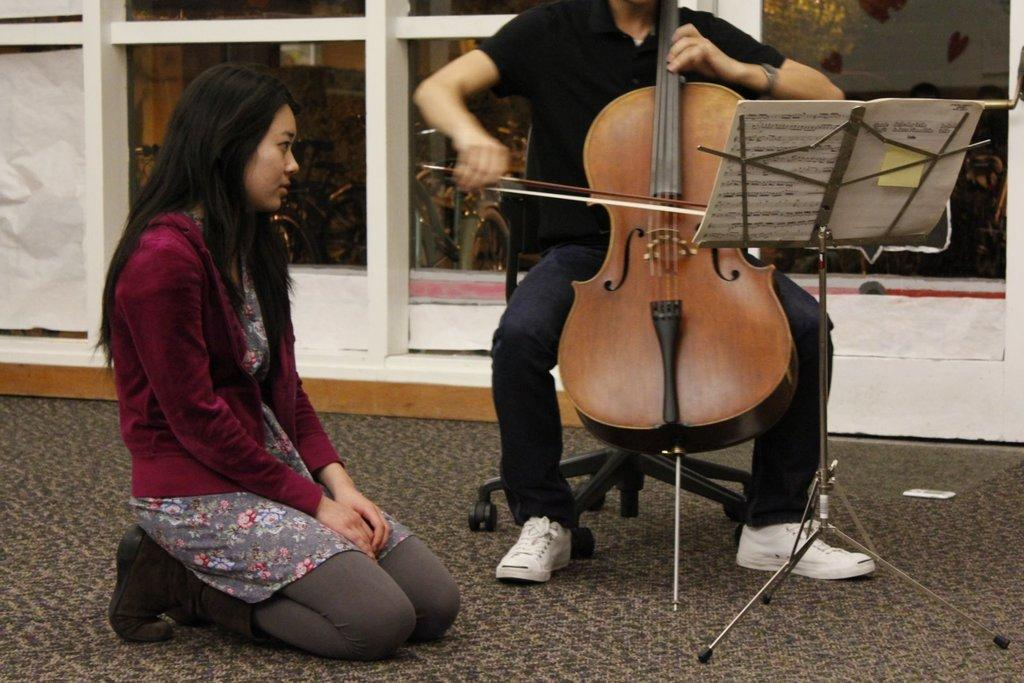What is the main activity being performed by the person in the image? There is a person playing guitar in the image. Can you describe the position of the other person in the image? There is another person sitting on the floor in the image. What object related to learning or reading can be seen in the image? There is a book in the image. What can be seen in the background of the image? There is a stand and a plant in the background of the image. What type of soup is being served in the image? There is no soup present in the image. Who is the uncle of the person playing guitar in the image? There is no information about an uncle in the image. 